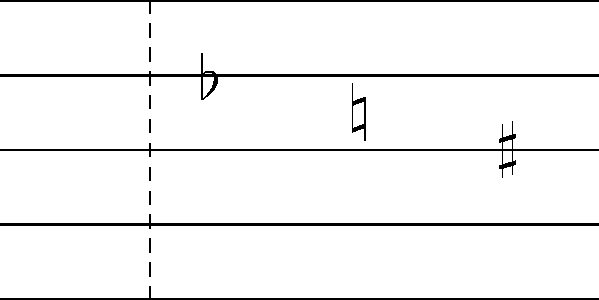Identify the musical notation symbols shown on the staff and explain their function in relation to pitch alteration. How might these symbols affect your piano performance in a collaborative literary-musical project? 1. The image shows a musical staff with three symbols:
   a) A flat ($\flat$) on the top space
   b) A natural ($\natural$) on the top line
   c) A sharp ($\sharp$) on the second line from the top

2. Functions of these symbols:
   a) Flat ($\flat$): Lowers the pitch of a note by a half step
   b) Natural ($\natural$): Cancels any previous alteration, returning the note to its natural state
   c) Sharp ($\sharp$): Raises the pitch of a note by a half step

3. Effect on piano performance:
   - These symbols indicate specific pitch alterations, crucial for accurate interpretation of the music
   - In a collaborative literary-musical project, precise execution of these alterations ensures harmony between the musical and literary elements
   - For a pianist, these symbols guide finger placement on the keyboard, affecting both black and white keys

4. Collaborative context:
   - Understanding these symbols is essential for maintaining tonal consistency with the literary themes
   - Accurate interpretation allows for seamless integration of music with spoken or written word in the project

5. Performance considerations:
   - Flats and sharps may require quick adjustments in hand position
   - Naturals might necessitate a return to previous hand positions
   - Awareness of these symbols helps in anticipating upcoming musical phrases and their relation to the literary content
Answer: Flat ($\flat$), Natural ($\natural$), Sharp ($\sharp$); alter pitch by lowering, canceling alterations, and raising, respectively; crucial for accurate musical interpretation in literary-musical collaborations. 